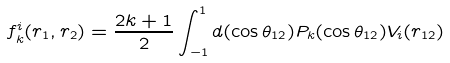Convert formula to latex. <formula><loc_0><loc_0><loc_500><loc_500>f _ { k } ^ { i } ( r _ { 1 } , r _ { 2 } ) = \frac { 2 k + 1 } { 2 } \int _ { - 1 } ^ { 1 } d ( \cos \theta _ { 1 2 } ) P _ { k } ( \cos \theta _ { 1 2 } ) V _ { i } ( r _ { 1 2 } )</formula> 